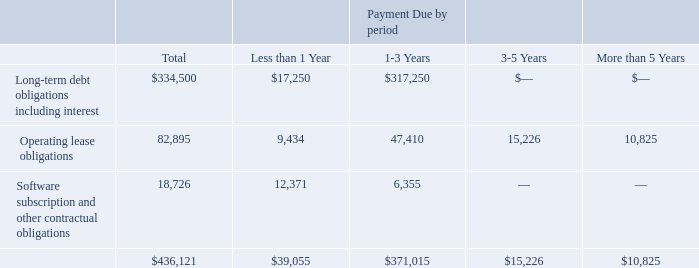Contractual Obligations
Our principal commitments consist of obligations for outstanding debt, leases for our office space, contractual commitments for professional service projects, and third-party consulting firms. The following table summarizes our contractual obligations at December 31, 2019 (in thousands):
What are the company's principal commitments? Obligations for outstanding debt, leases for our office space, contractual commitments for professional service projects, and third-party consulting firms. What were the operating lease obligations for periods more than 5 years?
Answer scale should be: thousand. 10,825. What was the software subscription and other contractual obligations for periods less than 1 year?
Answer scale should be: thousand. 12,371. What is the sum of total operating lease obligations and Long-term debt obligations including interest?
Answer scale should be: thousand. 82,895+$334,500
Answer: 417395. What is the percentage of the total obligations that consists of software subscription and other contractual obligations?
Answer scale should be: percent. (18,726/436,121)
Answer: 4.29. What is the percentage of the total obligations that consists of payments due in 1-3 years?
Answer scale should be: percent. (371,015/436,121)
Answer: 85.07. 